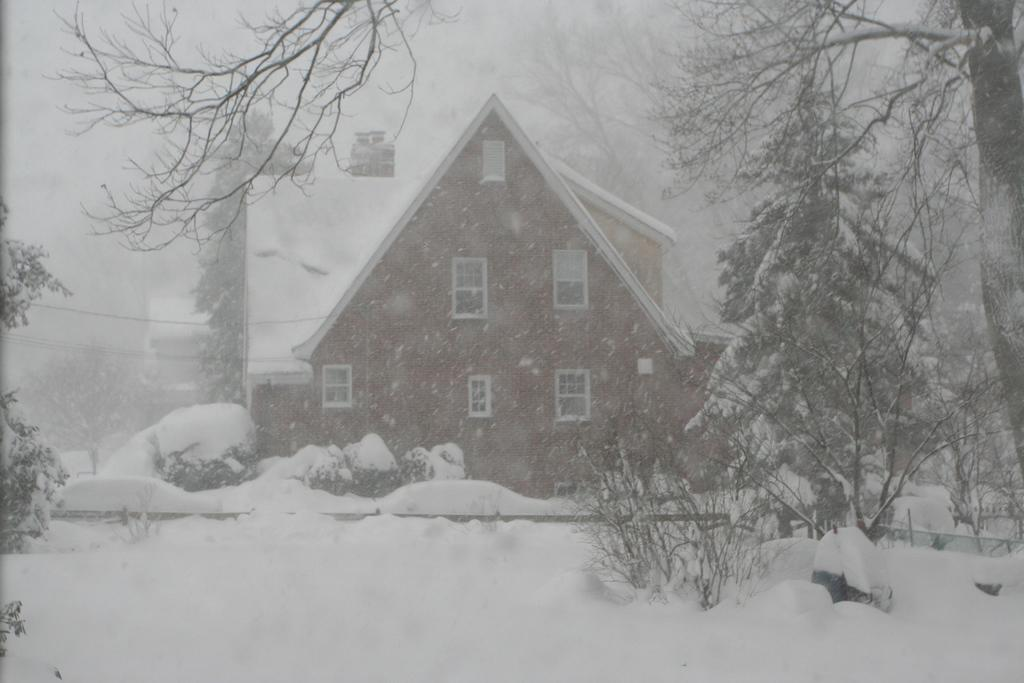What type of structure is present in the image? There is a building in the image. What feature can be seen on the building? The building has windows. What is the predominant color in the image? The image is dominated by snow, which is white in color. What type of natural elements can be seen in the image? There are trees visible in the image. What type of skirt is the woman wearing in the image? There is no woman present in the image, so it is not possible to determine what type of skirt she might be wearing. 